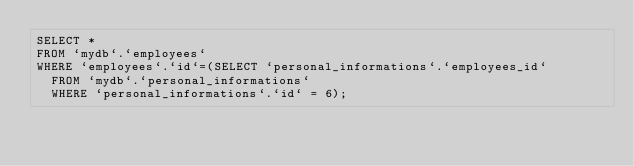<code> <loc_0><loc_0><loc_500><loc_500><_SQL_>SELECT *
FROM `mydb`.`employees`
WHERE `employees`.`id`=(SELECT `personal_informations`.`employees_id`
	FROM `mydb`.`personal_informations`
	WHERE `personal_informations`.`id` = 6);
</code> 